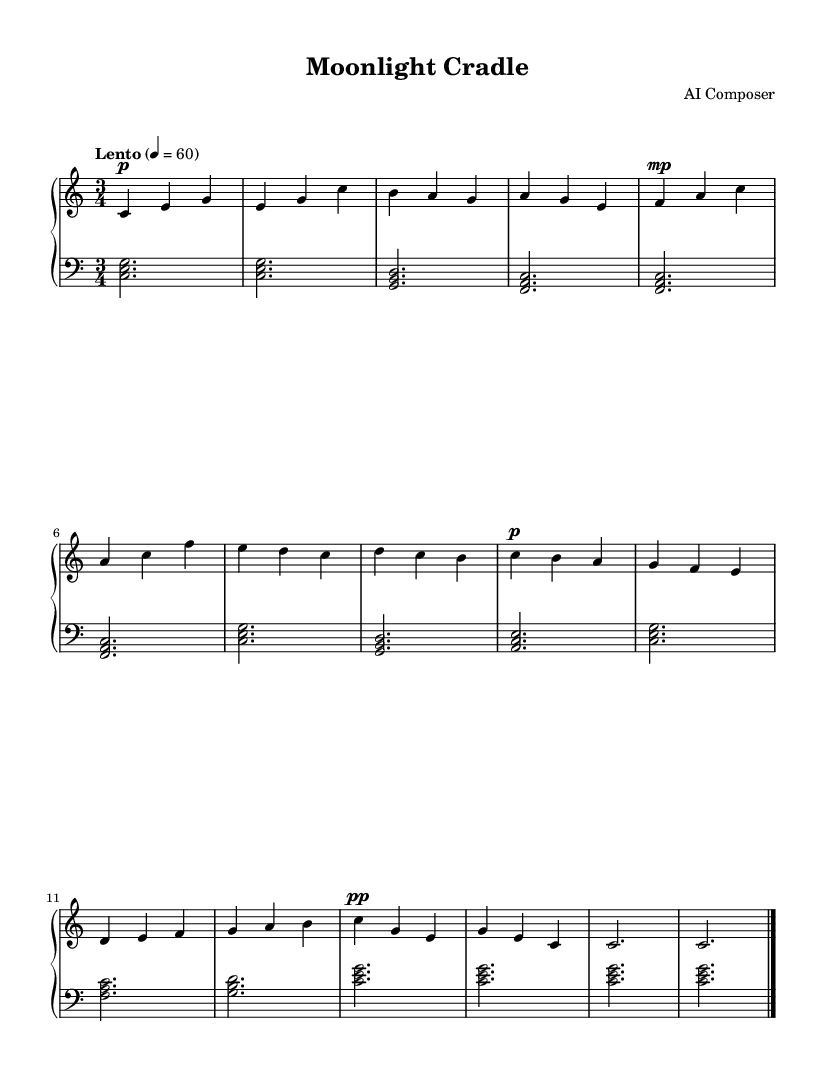What is the key signature of this music? The key signature is C major, which has no sharps or flats.
Answer: C major What is the time signature of this piece? The time signature is indicated at the beginning of the piece, where it shows 3/4, meaning there are three beats in each measure.
Answer: 3/4 What is the tempo marking for this composition? The tempo marking is "Lento", which indicates a slow pace, detailed with a number of beats per minute at 60.
Answer: Lento How many measures are present in the score? By counting the repeated patterns and the endings, there are a total of 14 measures in the score.
Answer: 14 What is the dynamic marking at the beginning of the right hand? The dynamic marking at the beginning of the right hand is "p," which stands for piano, meaning soft.
Answer: p Which technique is used for both the right and left hands? Both hands use a form of arpeggiation, indicated by the way chords are spread out and played over time.
Answer: Arpeggiation 